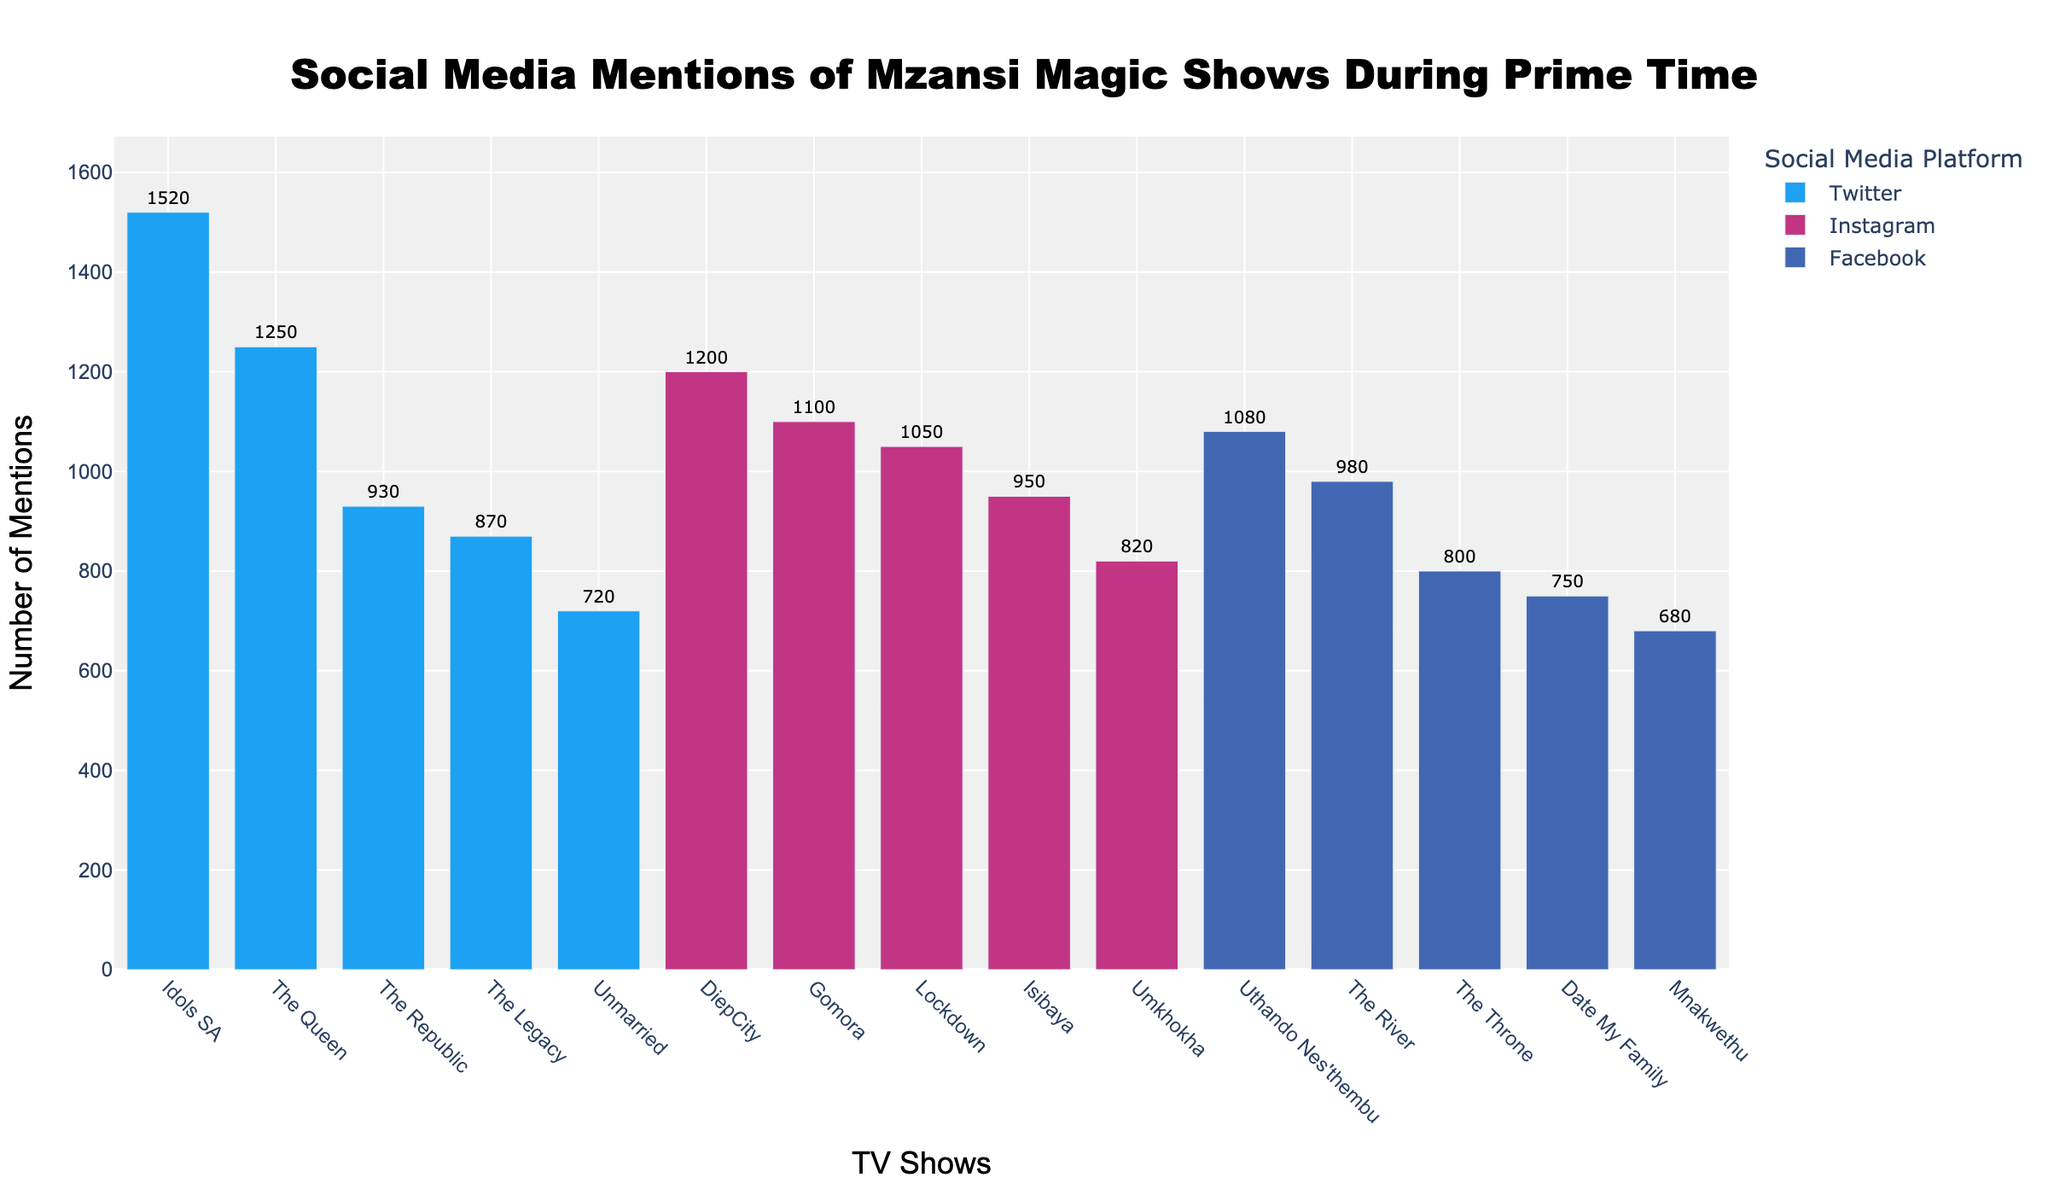What is the title of the plot? The title is usually placed at the top of the plot, centered and clearly labeled. In this figure, it is "Social Media Mentions of Mzansi Magic Shows During Prime Time".
Answer: Social Media Mentions of Mzansi Magic Shows During Prime Time Which show has the highest number of mentions on Twitter? To find this, look for the tallest bar under Twitter's color (light blue) and identify the corresponding show. "Idols SA" is the show with the highest mentions on Twitter with 1520 mentions.
Answer: Idols SA What is the combined number of mentions for the top three shows by mentions across any platform? Identify the top three bars on the plot and sum their mention values. These are "Idols SA" (1520), "The Queen" (1250), and "DiepCity" (1200). Adding these values together gives 1520 + 1250 + 1200 = 3970.
Answer: 3970 Which platform has the most mentions for "The River"? "The River" is mentioned under Facebook, denoted by the dark blue color bar. No other platforms have a bar labeled "The River" in this plot.
Answer: Facebook Compare the mentions of "Gomora" and "Date My Family". Which one is higher, and by how much? Look for both "Gomora" and "Date My Family" in the plot. "Gomora" (Instagram) has 1100 mentions, and "Date My Family" (Facebook) has 750 mentions. The difference between them is 1100 - 750 = 350.
Answer: "Gomora" is higher by 350 mentions What is the average number of mentions for the shows on Instagram? List the mentions for all shows on Instagram: 1100 (Gomora), 820 (Umkhokha), 1200 (DiepCity), 950 (Isibaya), 1050 (Lockdown). Add these values and divide by the number of shows: (1100 + 820 + 1200 + 950 + 1050) / 5 = 5120 / 5 = 1024.
Answer: 1024 How many shows have more than 900 mentions? Count all the bars that height (mentions) exceeds 900. These include, "Idols SA" (1520), "The Queen" (1250), "DiepCity" (1200), "Gomora" (1100), "The River" (980), "Isibaya" (950), "Lockdown" (1050), and "Uthando Nes'thembu" (1080), totaling 8 shows.
Answer: 8 Which platform has the least overall mentions and how many? Sum the mentions on each platform then compare. For Twitter (1250 + 1520 + 930 + 870 + 720 = 5290), Facebook (980 + 750 + 1080 + 680 + 800 = 4290), Instagram (1100 + 820 + 1200 + 950 + 1050 = 5120). Facebook has the least mentions with 4290 total mentions.
Answer: Facebook with 4290 